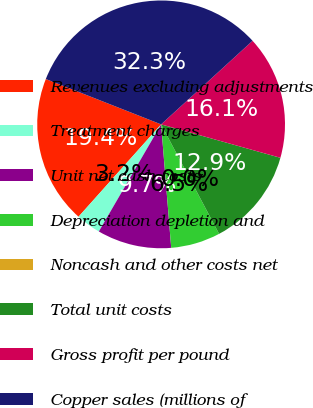Convert chart. <chart><loc_0><loc_0><loc_500><loc_500><pie_chart><fcel>Revenues excluding adjustments<fcel>Treatment charges<fcel>Unit net cash costs<fcel>Depreciation depletion and<fcel>Noncash and other costs net<fcel>Total unit costs<fcel>Gross profit per pound<fcel>Copper sales (millions of<nl><fcel>19.35%<fcel>3.23%<fcel>9.68%<fcel>6.45%<fcel>0.0%<fcel>12.9%<fcel>16.13%<fcel>32.25%<nl></chart> 